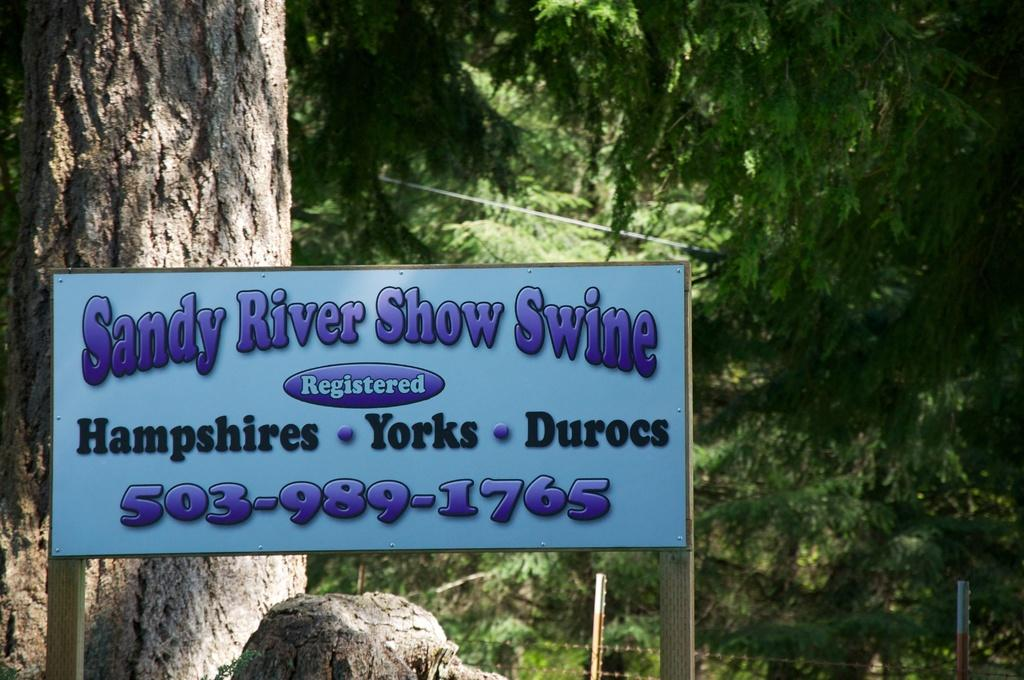What is the main object in the image? There is a board in the image. What is on the board? Something is written on the board. What natural element is visible in the image? There is a tree trunk visible in the image. What type of vegetation is present in the image? There are trees and plants in the image. Can you tell me how many cans are on the board in the image? There are no cans present on the board in the image; it has writing instead. What is the board instructing people to do in the image? The board does not instruct people to do anything in the image; it only has writing on it. 